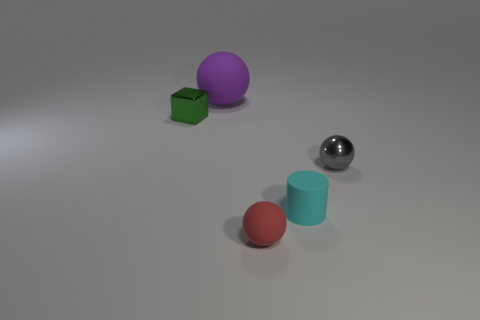Add 2 green matte things. How many objects exist? 7 Subtract all cubes. How many objects are left? 4 Add 2 blue blocks. How many blue blocks exist? 2 Subtract 0 blue cylinders. How many objects are left? 5 Subtract all small yellow metallic cubes. Subtract all small cyan matte cylinders. How many objects are left? 4 Add 4 large purple objects. How many large purple objects are left? 5 